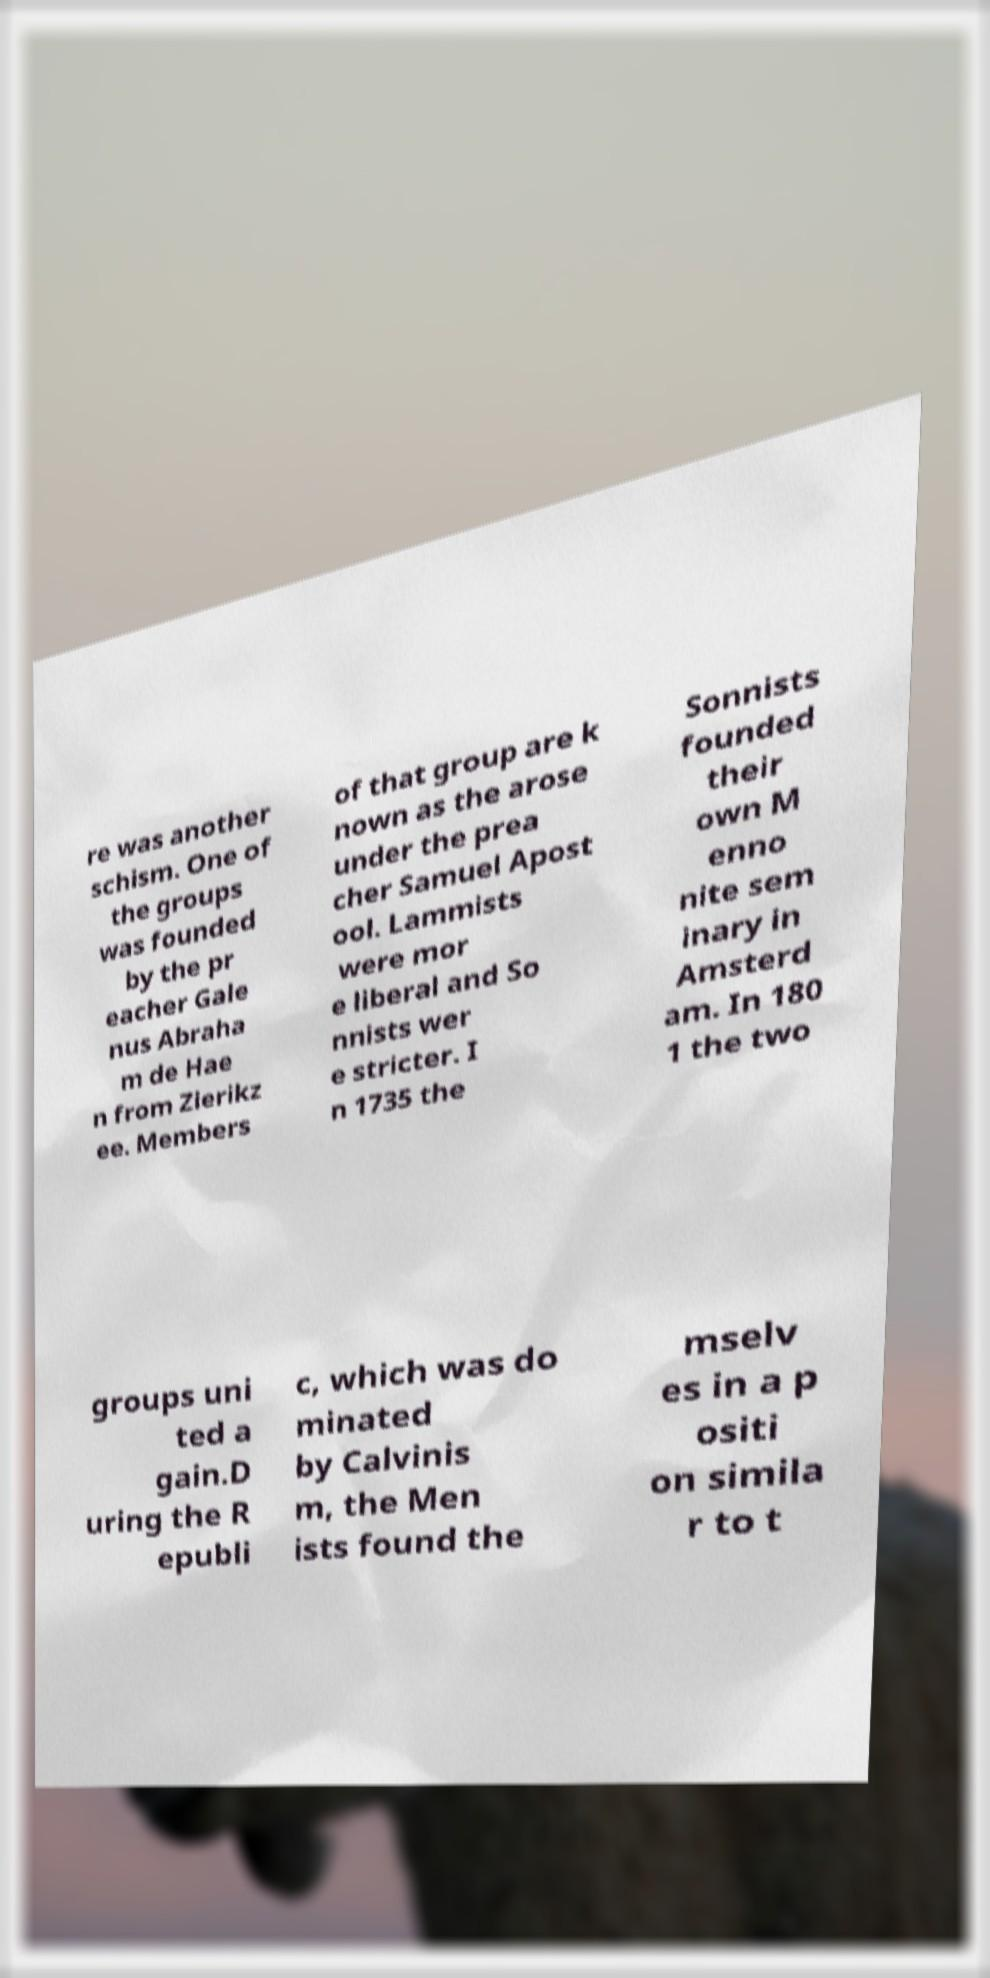I need the written content from this picture converted into text. Can you do that? re was another schism. One of the groups was founded by the pr eacher Gale nus Abraha m de Hae n from Zierikz ee. Members of that group are k nown as the arose under the prea cher Samuel Apost ool. Lammists were mor e liberal and So nnists wer e stricter. I n 1735 the Sonnists founded their own M enno nite sem inary in Amsterd am. In 180 1 the two groups uni ted a gain.D uring the R epubli c, which was do minated by Calvinis m, the Men ists found the mselv es in a p ositi on simila r to t 